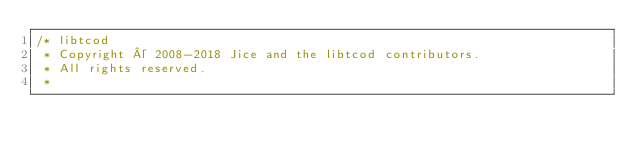<code> <loc_0><loc_0><loc_500><loc_500><_C++_>/* libtcod
 * Copyright © 2008-2018 Jice and the libtcod contributors.
 * All rights reserved.
 *</code> 